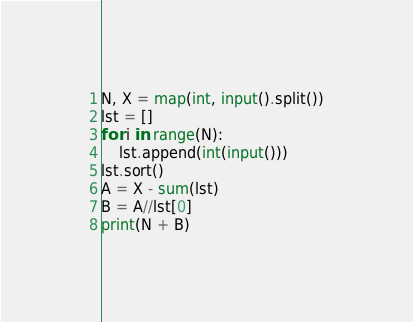Convert code to text. <code><loc_0><loc_0><loc_500><loc_500><_Python_>N, X = map(int, input().split())
lst = []
for i in range(N):
    lst.append(int(input()))
lst.sort()
A = X - sum(lst)
B = A//lst[0]
print(N + B)</code> 